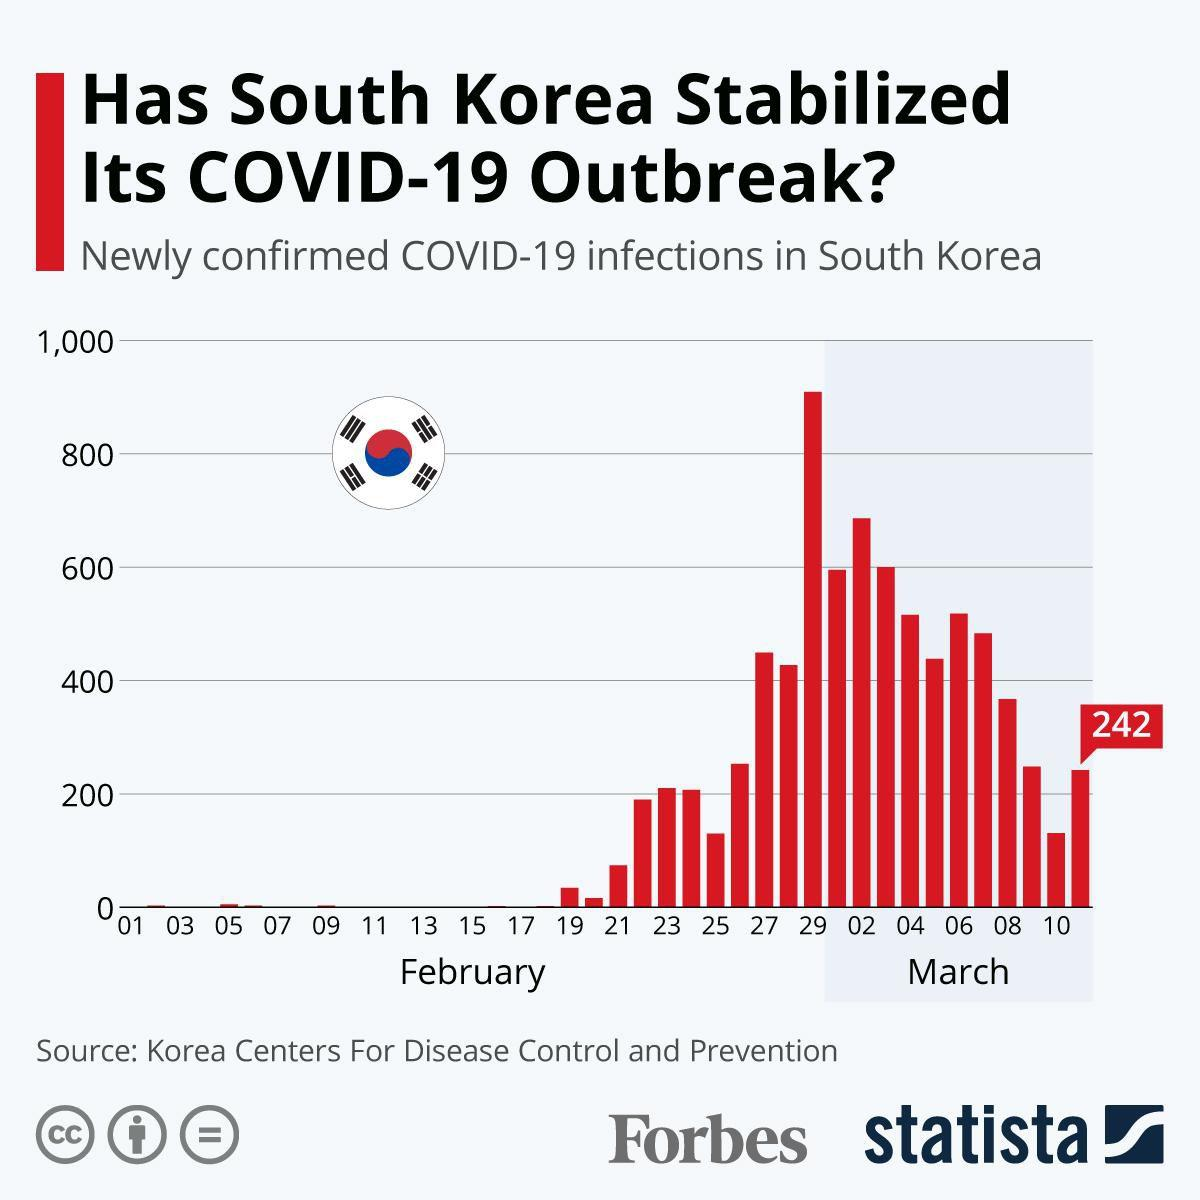Highlight a few significant elements in this photo. On March 11, there were 242 newly confirmed COVID-19 cases in South Korea. South Korea reported more than 600 newly confirmed COVID-19 cases on March 2, 2023. South Korea reported more than 800 newly confirmed COVID-19 cases on February 29th. 